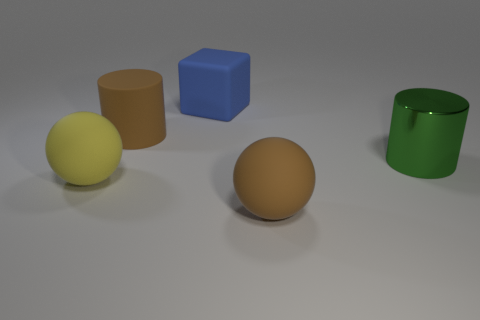Do the large green object and the brown rubber thing that is behind the yellow rubber sphere have the same shape?
Provide a short and direct response. Yes. The large cylinder that is made of the same material as the large blue object is what color?
Your answer should be very brief. Brown. The big cube is what color?
Your response must be concise. Blue. Is the material of the big cube the same as the sphere behind the large brown sphere?
Keep it short and to the point. Yes. What number of objects are both to the left of the brown ball and in front of the large green thing?
Offer a very short reply. 1. There is a green object that is the same size as the blue rubber block; what shape is it?
Keep it short and to the point. Cylinder. There is a big cylinder that is on the right side of the large blue rubber thing that is behind the big green object; is there a large blue matte object that is left of it?
Keep it short and to the point. Yes. Is the color of the rubber cylinder the same as the sphere that is in front of the yellow object?
Give a very brief answer. Yes. How many things have the same color as the rubber cylinder?
Ensure brevity in your answer.  1. What size is the brown object in front of the large brown object that is left of the blue cube?
Provide a succinct answer. Large. 